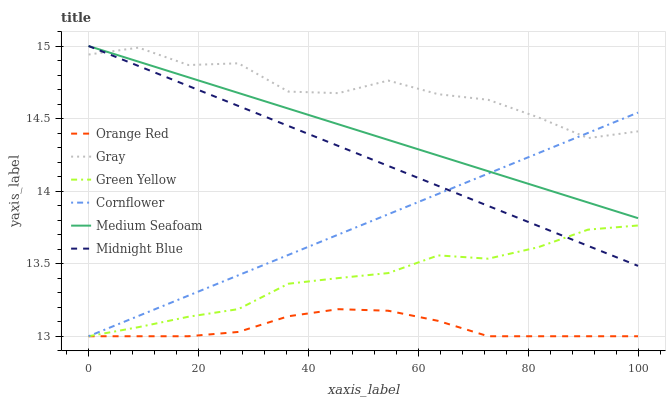Does Orange Red have the minimum area under the curve?
Answer yes or no. Yes. Does Gray have the maximum area under the curve?
Answer yes or no. Yes. Does Midnight Blue have the minimum area under the curve?
Answer yes or no. No. Does Midnight Blue have the maximum area under the curve?
Answer yes or no. No. Is Midnight Blue the smoothest?
Answer yes or no. Yes. Is Gray the roughest?
Answer yes or no. Yes. Is Cornflower the smoothest?
Answer yes or no. No. Is Cornflower the roughest?
Answer yes or no. No. Does Cornflower have the lowest value?
Answer yes or no. Yes. Does Midnight Blue have the lowest value?
Answer yes or no. No. Does Medium Seafoam have the highest value?
Answer yes or no. Yes. Does Cornflower have the highest value?
Answer yes or no. No. Is Green Yellow less than Medium Seafoam?
Answer yes or no. Yes. Is Gray greater than Green Yellow?
Answer yes or no. Yes. Does Cornflower intersect Gray?
Answer yes or no. Yes. Is Cornflower less than Gray?
Answer yes or no. No. Is Cornflower greater than Gray?
Answer yes or no. No. Does Green Yellow intersect Medium Seafoam?
Answer yes or no. No. 